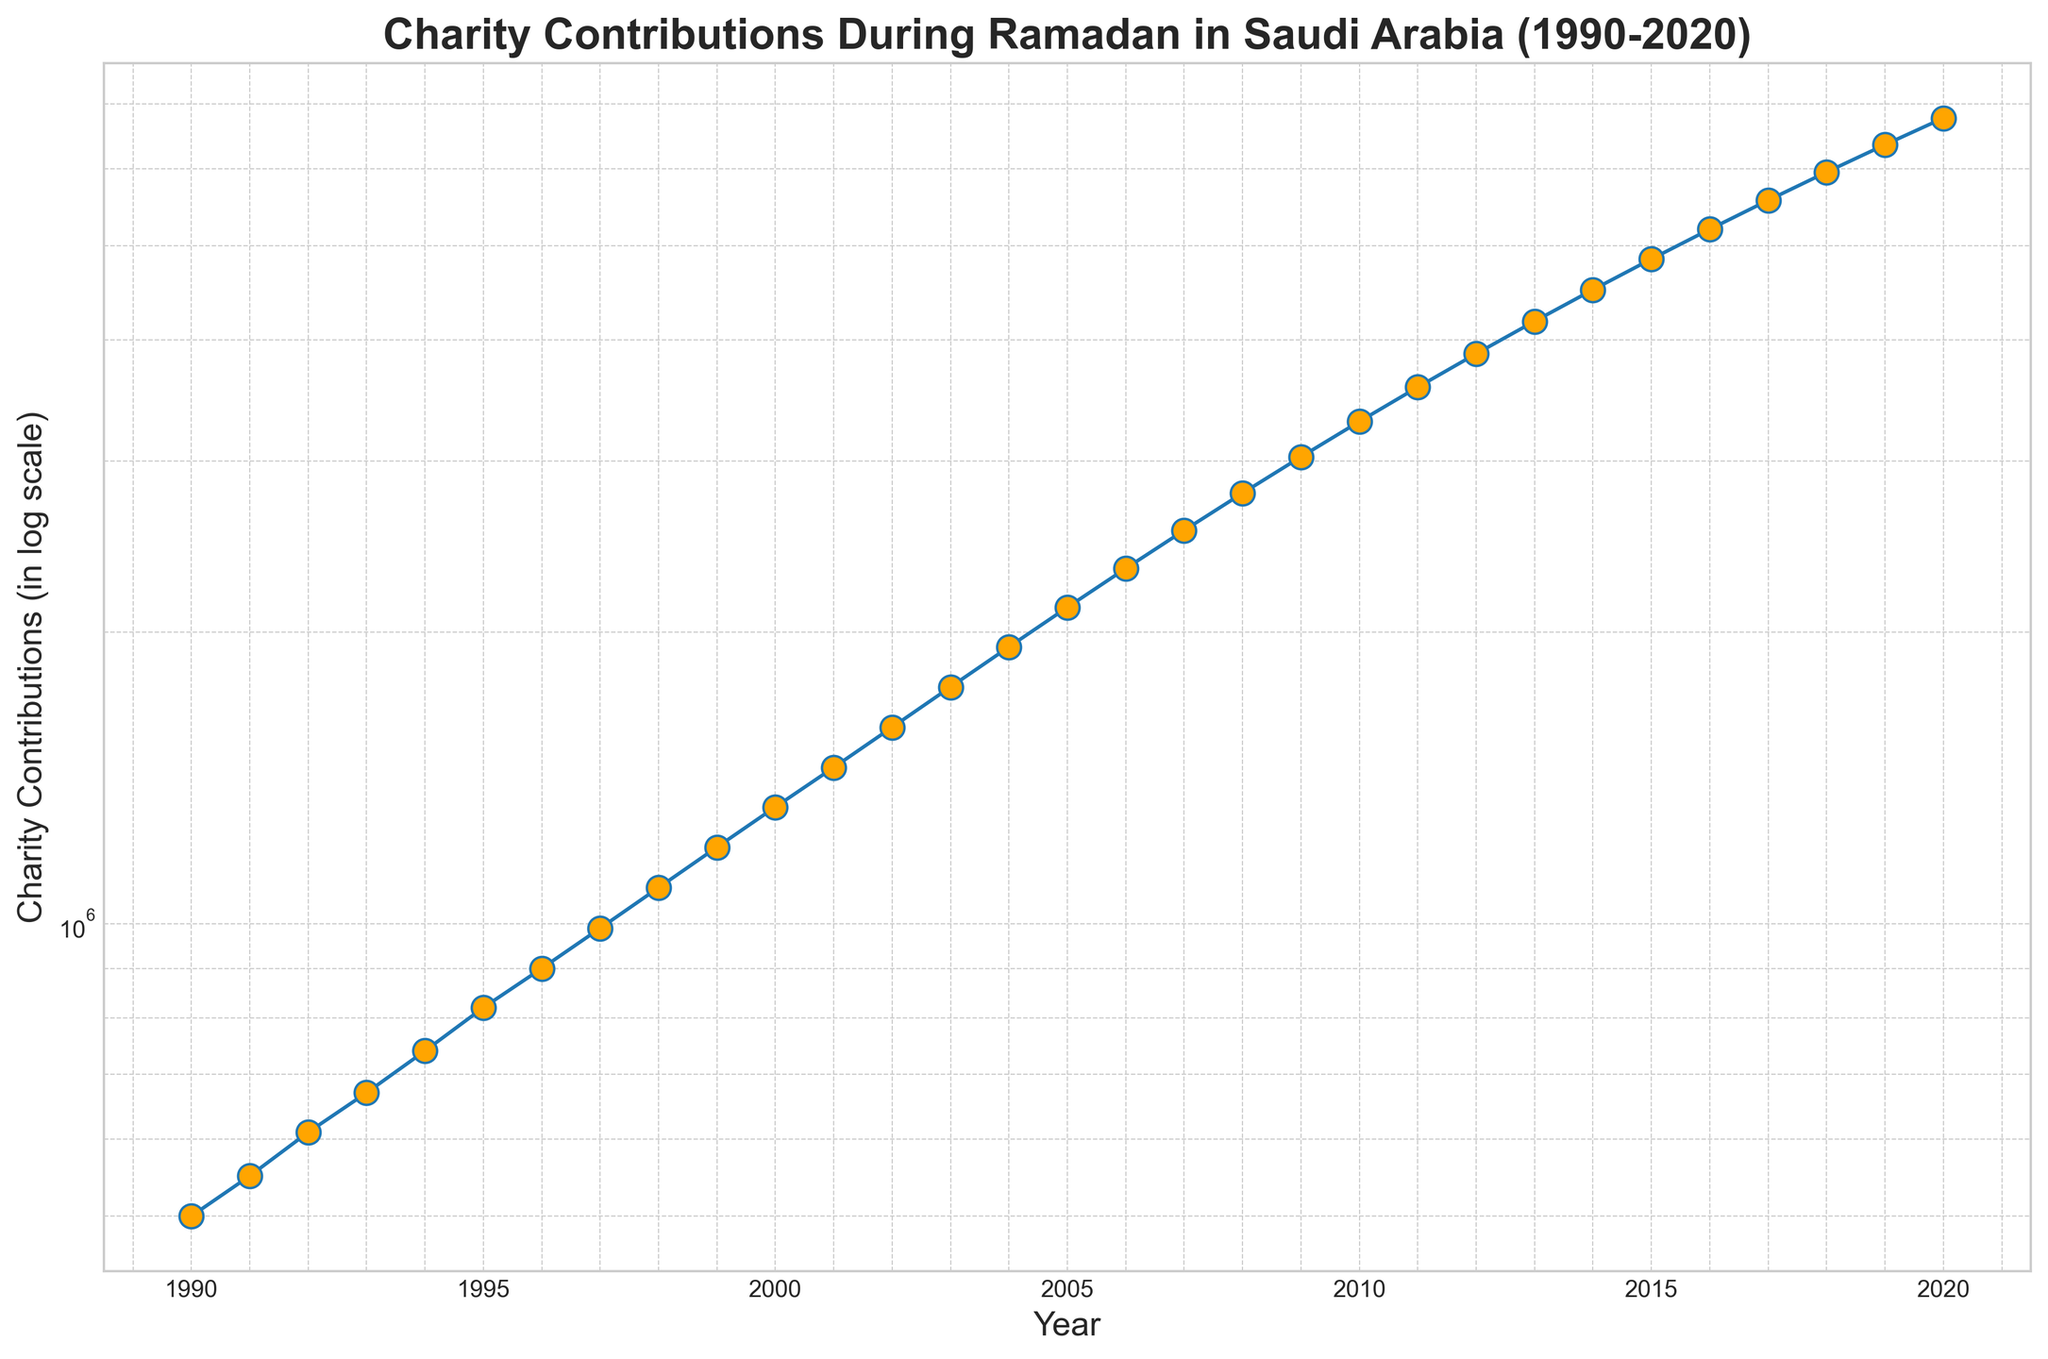What pattern do you see in the Charity Contributions from 1990 to 2020? The contributions show a steady increase over the years. On a log scale, the trend appears to be exponential growth. We can observe that there is a continuous upward trend with no sharp decline between any consecutive years.
Answer: Steady exponential increase In which year did the charity contributions cross the 1 million mark for the first time? By examining the figure, the contribution first surpasses 1,000,000 in 1998. Prior years show contributions below this threshold.
Answer: 1998 Can you identify any years where there was a decline in the contributions compared to the previous year? The figure shows that every subsequent year has higher contributions than the previous year; thus, there are no declines in contributions during the period from 1990 to 2020.
Answer: No What is the difference in charity contributions between the years 2000 and 2010? According to the figure, the contributions in 2000 were 1,320,000, and in 2010, it was 3,295,000. Therefore, the difference is 3,295,000 - 1,320,000 = 1,975,000.
Answer: 1,975,000 What is the visual pattern of the markers representing each year’s contribution? Each year’s contribution is represented by markers that are orange circles connected by a blue line on the log scale graph. The markers are equally spaced horizontally but increase exponentially on the vertical axis.
Answer: Orange circles on blue line Between 1995 and 2005, which year observed the highest charity contribution and what was its value? In the given years, 2005 observed the highest charity contribution according to the figure, with a value of 2,120,000.
Answer: 2005, 2,120,000 What is the overall trend in charity contributions when comparing the start and end of the recorded period? Comparing 1990 and 2020, the chart shows an exponential growth in contributions, moving from 500,000 in 1990 to 6,770,000 in 2020.
Answer: Exponential growth How much did charity contributions increase by from 1993 to 1995? In 1993, contributions were 670,000, and in 1995, they were 820,000. The increase is 820,000 - 670,000 = 150,000.
Answer: 150,000 